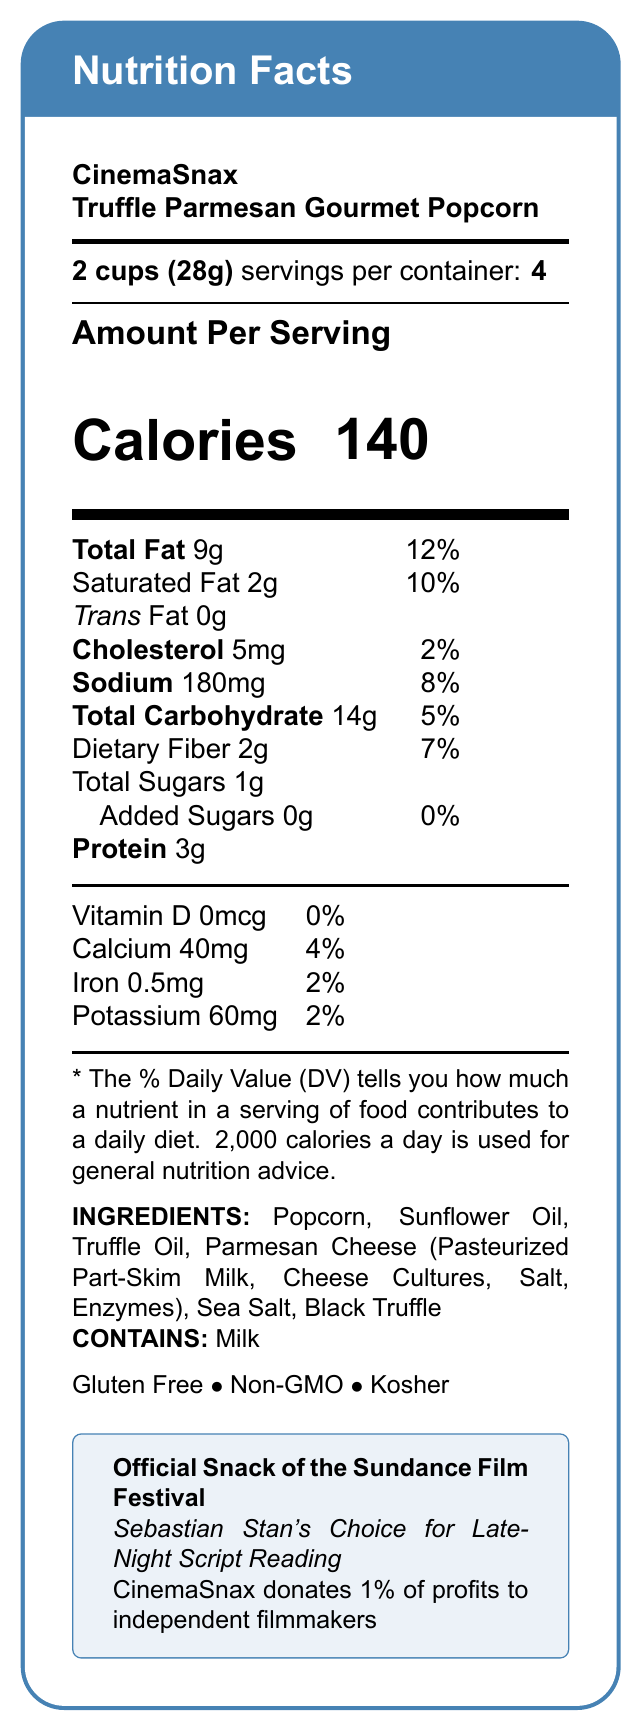Who makes the Truffle Parmesan Gourmet Popcorn? The brand name listed is CinemaSnax.
Answer: CinemaSnax What is the serving size for the Truffle Parmesan Gourmet Popcorn? The document specifies a serving size of 2 cups (28g).
Answer: 2 cups (28g) How many servings are in one container of the Truffle Parmesan Gourmet Popcorn? The document indicates there are 4 servings per container.
Answer: 4 What is the total fat content per serving? The total fat content per serving is listed as 9g.
Answer: 9g How many calories are there per serving? The document states there are 140 calories per serving.
Answer: 140 What type of dietary fiber percentage is present per serving? The daily value percentage for dietary fiber per serving is 7%.
Answer: 7% Does the Truffle Parmesan Gourmet Popcorn contain any trans fat? The document specifically states there are 0g of trans fat per serving.
Answer: No What allergens are present in the Truffle Parmesan Gourmet Popcorn? The document notes that the product contains milk.
Answer: Milk Which nutrient in the Truffle Parmesan Gourmet Popcorn contributes 2% to the daily value? A. Vitamin D B. Iron C. Cholesterol Cholesterol contributes 2% to the daily value per serving.
Answer: C Is the Truffle Parmesan Gourmet Popcorn gluten-free? The document indicates that the popcorn is gluten-free.
Answer: Yes Explain the key nutritional components listed in the document for the Truffle Parmesan Gourmet Popcorn. The main nutritional information section breaks down the key components per serving, specifying the amounts and daily values.
Answer: The Truffle Parmesan Gourmet Popcorn from CinemaSnax has 140 calories per serving, 9g of total fat, 2g of saturated fat, 5mg of cholesterol, 180mg of sodium, 14g of total carbohydrates (including 2g of dietary fiber and 1g of total sugars with no added sugars), and 3g of protein. It contains calcium, iron, and potassium. What is the official snack of the Sundance Film Festival? The document states that CinemaSnax Truffle Parmesan Gourmet Popcorn is the official snack of the Sundance Film Festival.
Answer: CinemaSnax Truffle Parmesan Gourmet Popcorn How much calcium does one serving of Truffle Parmesan Gourmet Popcorn provide? The document specifies that one serving contains 40mg of calcium.
Answer: 40mg Who endorses CinemaSnax Truffle Parmesan Gourmet Popcorn for late-night script reading? The document mentions that Sebastian Stan endorses the product for late-night script reading.
Answer: Sebastian Stan What percentage of profits does CinemaSnax donate to independent filmmakers? The document states that CinemaSnax donates 1% of its profits to independent filmmakers.
Answer: 1% How many grams of protein are in each serving? A. 1g B. 2g C. 3g D. 4g The document lists the protein content as 3g per serving.
Answer: C Does the Truffle Parmesan Gourmet Popcorn contain any added sugars? The document indicates that there are 0g of added sugars in the product.
Answer: No Identify the ingredients used in the Truffle Parmesan Gourmet Popcorn. The document lists all the ingredients used.
Answer: Popcorn, Sunflower Oil, Truffle Oil, Parmesan Cheese (Pasteurized Part-Skim Milk, Cheese Cultures, Salt, Enzymes), Sea Salt, Black Truffle Summarize the main features and additional information provided for the Truffle Parmesan Gourmet Popcorn from CinemaSnax. The document outlines nutritional details, ingredients, and additional notable features of the Truffle Parmesan Gourmet Popcorn product.
Answer: The Truffle Parmesan Gourmet Popcorn from CinemaSnax, the official snack of the Sundance Film Festival and endorsed by Sebastian Stan, is a gourmet treat with a serving size of 2 cups (28g) per serving and contains 140 calories. Notable nutritional details include 9g of total fat, 14g of carbohydrates, and 3g of protein. The product is gluten-free, non-GMO, and kosher, and contains milk as an allergen. CinemaSnax also donates 1% of its profits to independent filmmakers. What is the price of one container of Truffle Parmesan Gourmet Popcorn? The document does not provide pricing information.
Answer: Not enough information 